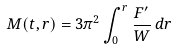<formula> <loc_0><loc_0><loc_500><loc_500>M ( t , r ) = 3 \pi ^ { 2 } \int _ { 0 } ^ { r } \frac { F ^ { \prime } } { W } \, d r</formula> 